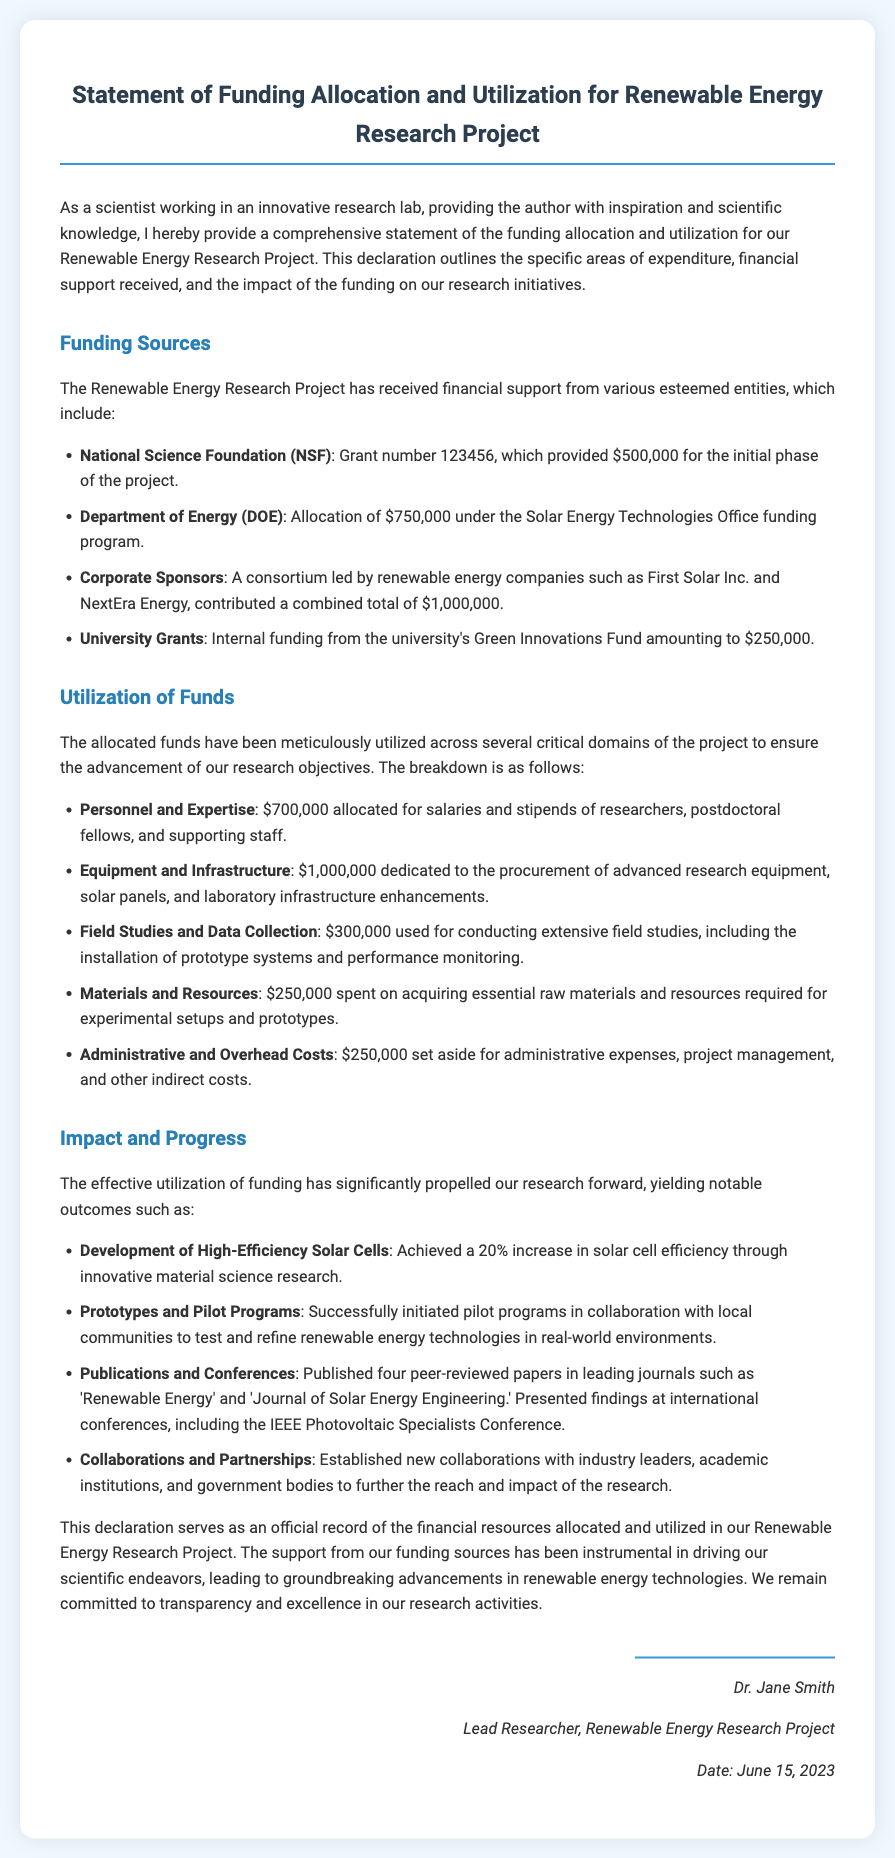What is the total funding received from the National Science Foundation? The funding from the National Science Foundation is specified in the document as $500,000.
Answer: $500,000 How much was allocated by the Department of Energy? The document states that the Department of Energy provided an allocation of $750,000.
Answer: $750,000 What is the total amount from Corporate Sponsors? The combined total contribution from Corporate Sponsors is stated as $1,000,000.
Answer: $1,000,000 What percentage increase in solar cell efficiency was achieved? The document indicates a 20% increase in solar cell efficiency was achieved.
Answer: 20% How much funding was used for Personnel and Expertise? The document mentions that $700,000 was allocated for salaries and stipends of researchers and staff.
Answer: $700,000 What is the total amount spent on Field Studies and Data Collection? The Field Studies and Data Collection section specifies an expenditure of $300,000.
Answer: $300,000 Who is the lead researcher for the Renewable Energy Research Project? The document indicates that Dr. Jane Smith is the lead researcher.
Answer: Dr. Jane Smith What date was the declaration signed? The signature section of the document lists the date as June 15, 2023.
Answer: June 15, 2023 What type of research advancements does the declaration emphasize? The declaration emphasizes advancements in renewable energy technologies.
Answer: Renewable energy technologies 